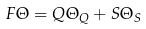<formula> <loc_0><loc_0><loc_500><loc_500>F \Theta = Q \Theta _ { Q } + S \Theta _ { S }</formula> 